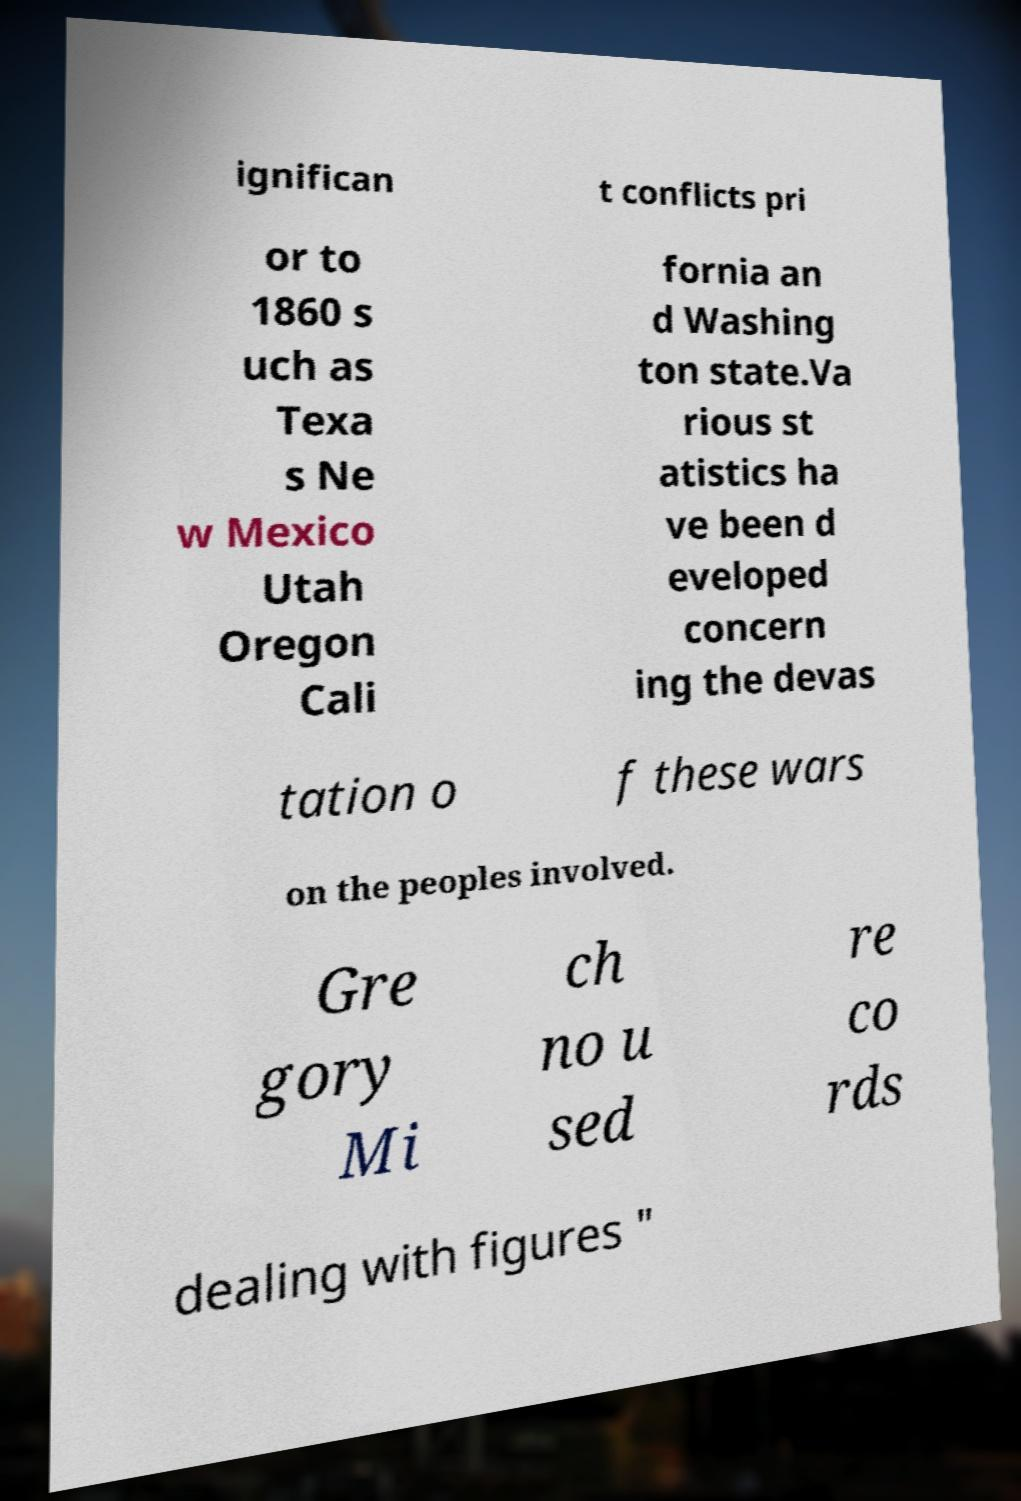There's text embedded in this image that I need extracted. Can you transcribe it verbatim? ignifican t conflicts pri or to 1860 s uch as Texa s Ne w Mexico Utah Oregon Cali fornia an d Washing ton state.Va rious st atistics ha ve been d eveloped concern ing the devas tation o f these wars on the peoples involved. Gre gory Mi ch no u sed re co rds dealing with figures " 